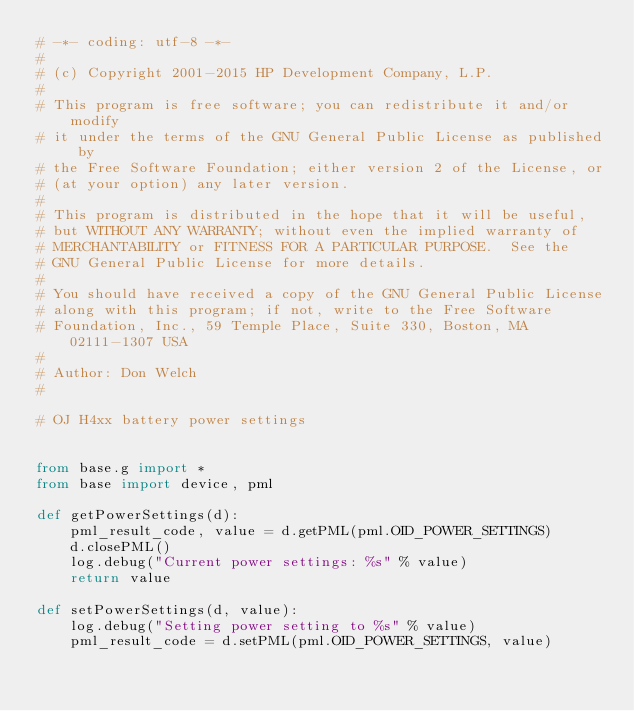<code> <loc_0><loc_0><loc_500><loc_500><_Python_># -*- coding: utf-8 -*-
#
# (c) Copyright 2001-2015 HP Development Company, L.P.
#
# This program is free software; you can redistribute it and/or modify
# it under the terms of the GNU General Public License as published by
# the Free Software Foundation; either version 2 of the License, or
# (at your option) any later version.
#
# This program is distributed in the hope that it will be useful,
# but WITHOUT ANY WARRANTY; without even the implied warranty of
# MERCHANTABILITY or FITNESS FOR A PARTICULAR PURPOSE.  See the
# GNU General Public License for more details.
#
# You should have received a copy of the GNU General Public License
# along with this program; if not, write to the Free Software
# Foundation, Inc., 59 Temple Place, Suite 330, Boston, MA  02111-1307 USA
#
# Author: Don Welch
#

# OJ H4xx battery power settings


from base.g import *
from base import device, pml

def getPowerSettings(d):
    pml_result_code, value = d.getPML(pml.OID_POWER_SETTINGS)
    d.closePML()
    log.debug("Current power settings: %s" % value)
    return value

def setPowerSettings(d, value):
    log.debug("Setting power setting to %s" % value)
    pml_result_code = d.setPML(pml.OID_POWER_SETTINGS, value)</code> 